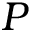<formula> <loc_0><loc_0><loc_500><loc_500>P</formula> 